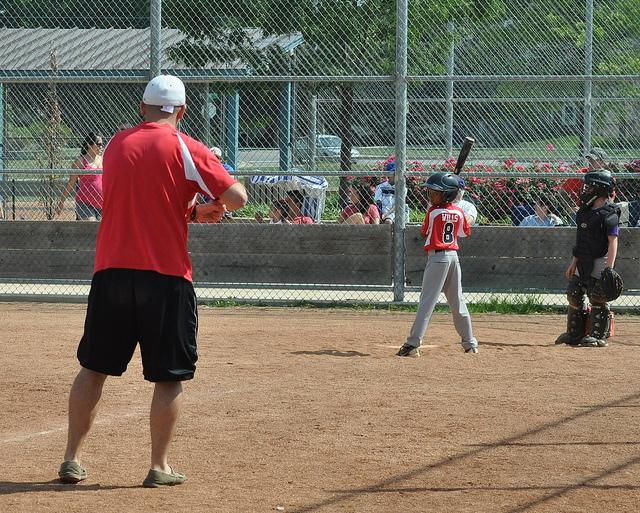What type of field are the kids playing on? baseball 